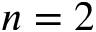<formula> <loc_0><loc_0><loc_500><loc_500>n = 2</formula> 